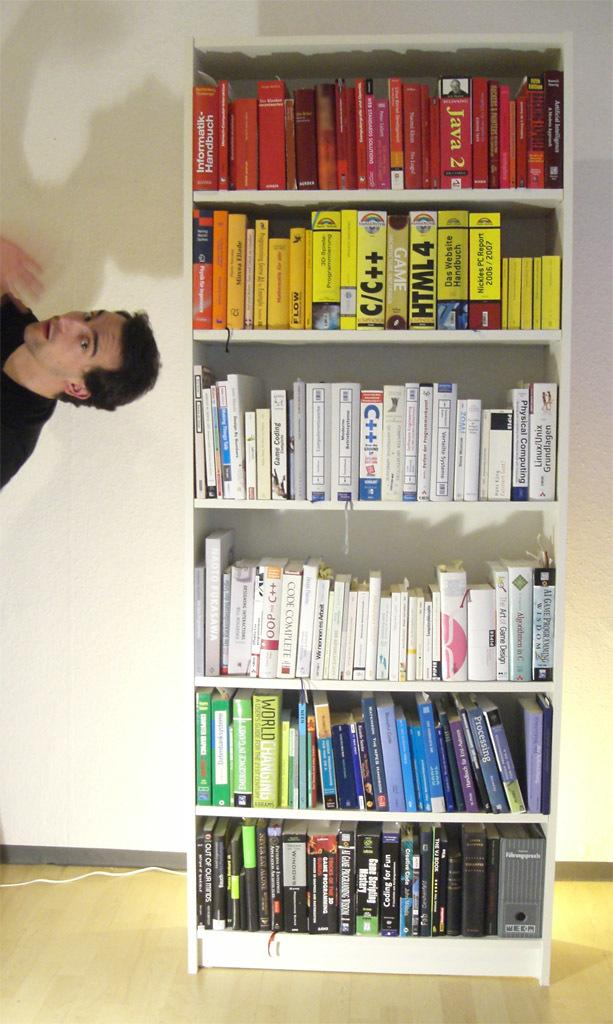<image>
Present a compact description of the photo's key features. A man is to the left of a bookshelf that contains books about HTML and C++. 